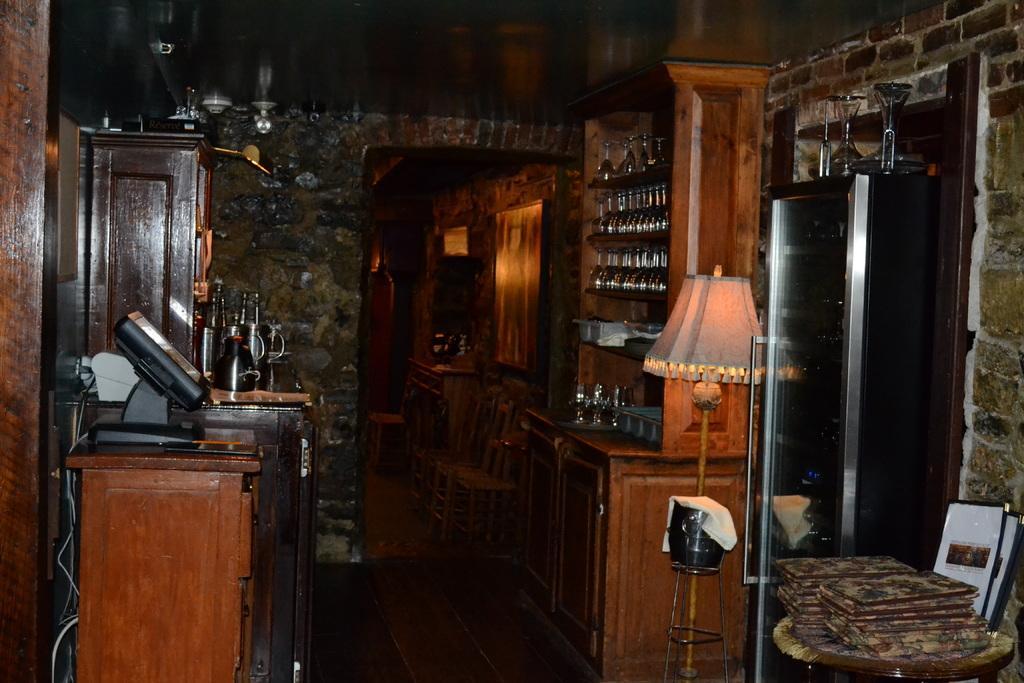Could you give a brief overview of what you see in this image? In the picture I can see the books on the wooden round table on the bottom right side. There is a table lamp on the right side. I can see the wine glasses on the wooden shelves on the right side. I can see an electronic device on the wooden drawer on the left side. In the background, I can see another wooden drawer. There are wooden chairs on the floor. 